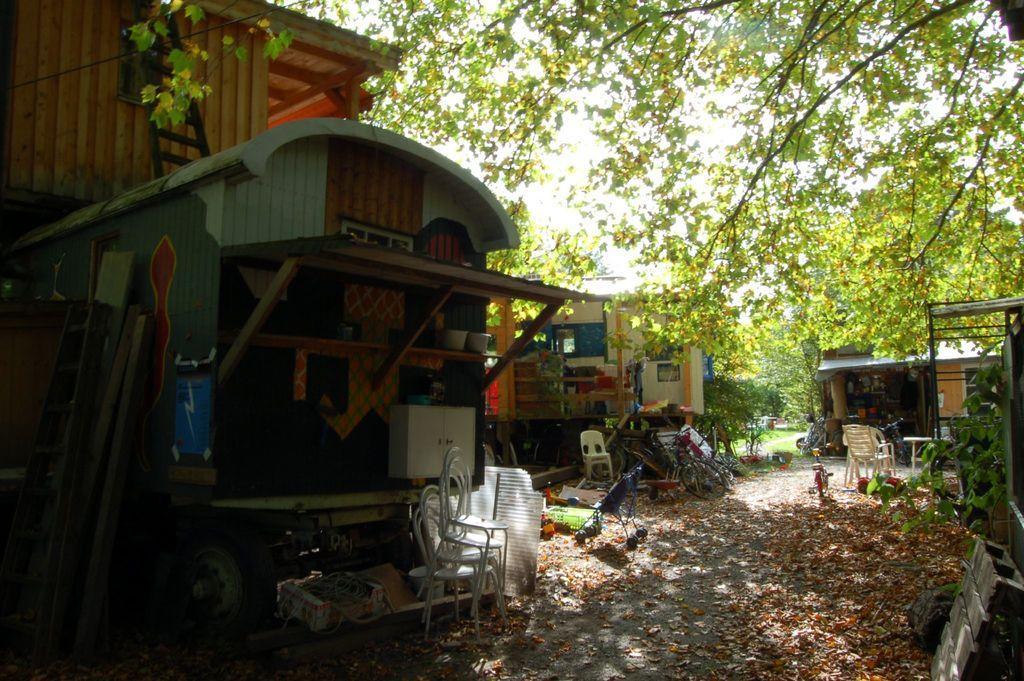Could you give a brief overview of what you see in this image? On the left side there is a building. There are ladders, wooden poles. There is a tire. On the building there is a rack. On that there are many items. Also there is a cupboard. Near to that there are chairs. On the ground there are leaves. Near to that there is a stroller. In the back there are buildings. There are chairs, cycle. On the right side there is a tree. In the background there are trees. 